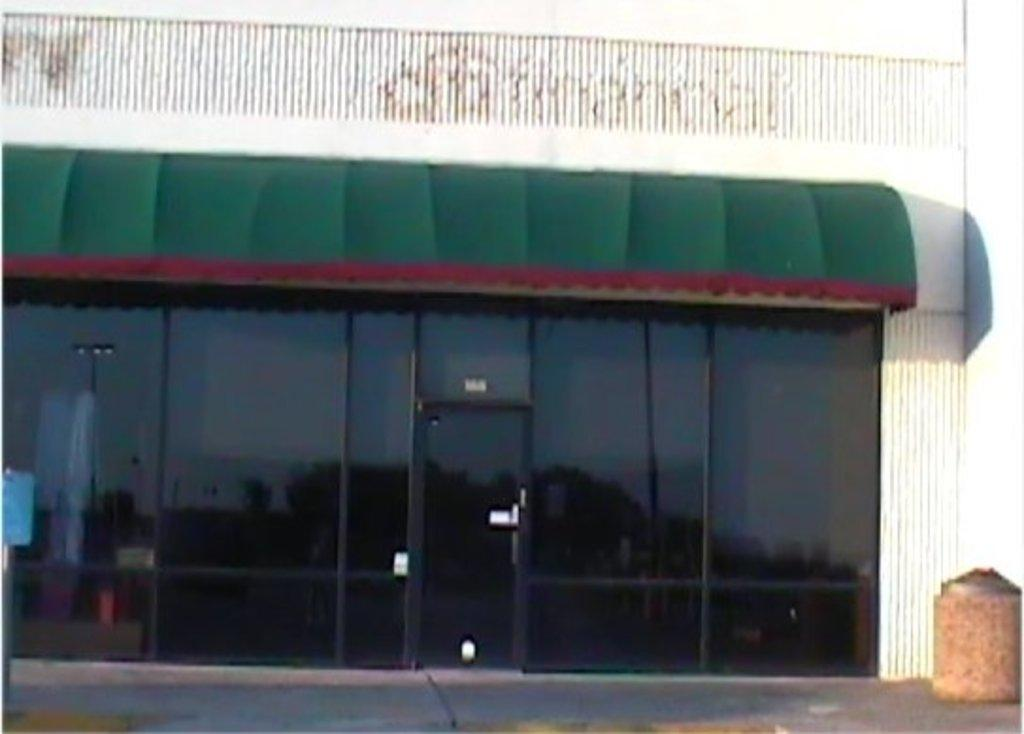What is the main subject of the image? The main subject of the image is an outside view of a garage. What can be seen in front of the garage? There is a black color gate in front of the garage. What is located above the garage in the image? There is a green color canopy shed above the garage. How many laborers are working inside the garage in the image? There are no laborers present in the image, as it only shows an outside view of the garage. How long does it take for the green color canopy shed to print a document in the image? There is no printer or document present in the image, so it is not possible to determine how long it would take to print a document. 